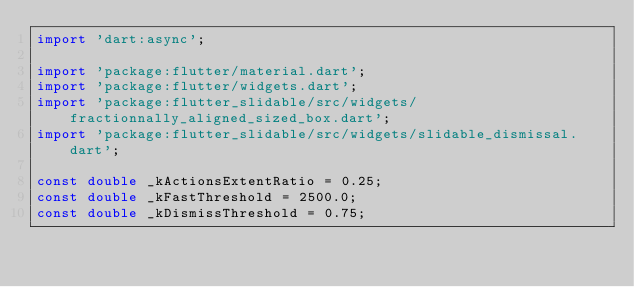Convert code to text. <code><loc_0><loc_0><loc_500><loc_500><_Dart_>import 'dart:async';

import 'package:flutter/material.dart';
import 'package:flutter/widgets.dart';
import 'package:flutter_slidable/src/widgets/fractionnally_aligned_sized_box.dart';
import 'package:flutter_slidable/src/widgets/slidable_dismissal.dart';

const double _kActionsExtentRatio = 0.25;
const double _kFastThreshold = 2500.0;
const double _kDismissThreshold = 0.75;</code> 